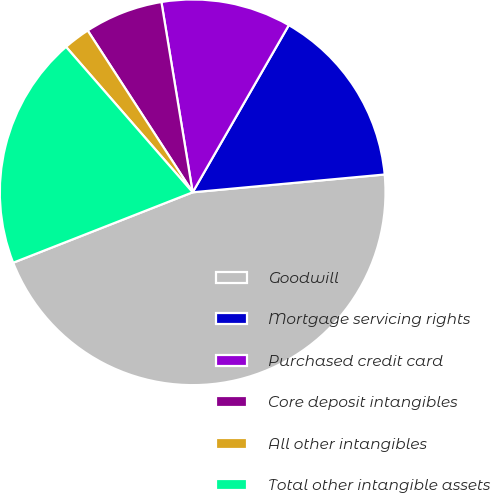Convert chart. <chart><loc_0><loc_0><loc_500><loc_500><pie_chart><fcel>Goodwill<fcel>Mortgage servicing rights<fcel>Purchased credit card<fcel>Core deposit intangibles<fcel>All other intangibles<fcel>Total other intangible assets<nl><fcel>45.52%<fcel>15.22%<fcel>10.9%<fcel>6.57%<fcel>2.24%<fcel>19.55%<nl></chart> 